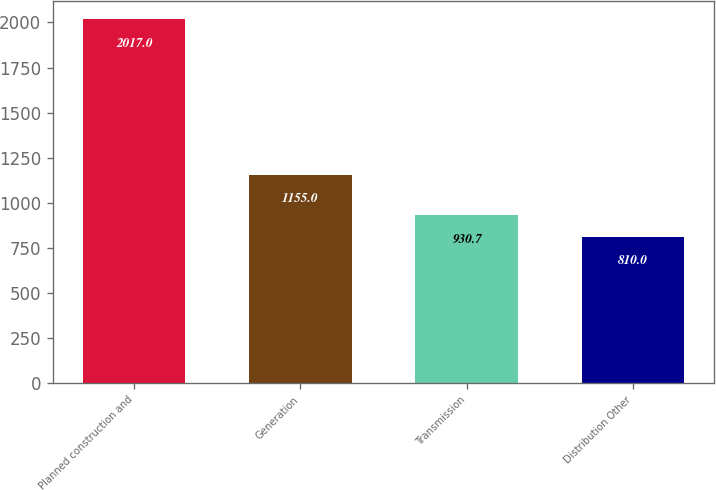Convert chart. <chart><loc_0><loc_0><loc_500><loc_500><bar_chart><fcel>Planned construction and<fcel>Generation<fcel>Transmission<fcel>Distribution Other<nl><fcel>2017<fcel>1155<fcel>930.7<fcel>810<nl></chart> 